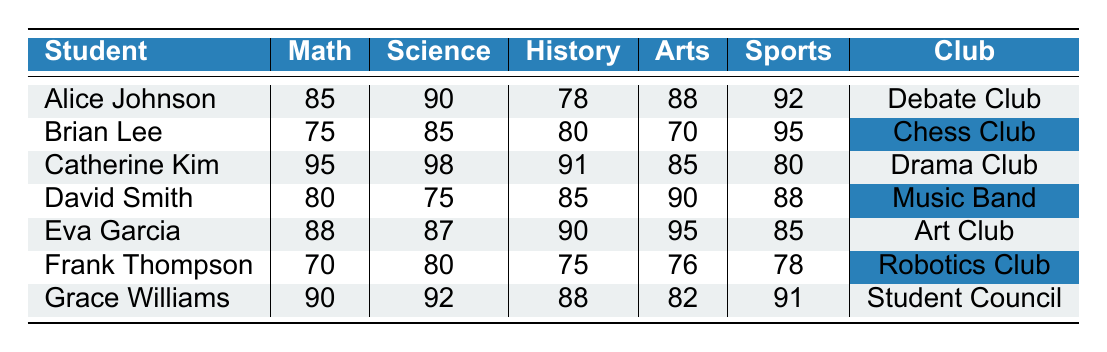What is the highest score in math? The "math" column lists all the students' scores in math. The highest score is 95, achieved by Catherine Kim.
Answer: 95 Which extracurricular club does David Smith participate in? David Smith's entry in the table shows his club participation as "Music Band."
Answer: Music Band What is the average score in sports for students in the Debate Club and Drama Club? Looking at the "sports" scores, Alice Johnson (Debate Club) has a score of 92 and Catherine Kim (Drama Club) has a score of 80. The average is calculated as (92 + 80) / 2 = 86.
Answer: 86 Is Catherine Kim's score in science higher than Eva Garcia's score in arts? Catherine Kim's score in science is 98, while Eva Garcia's score in arts is 95. Since 98 is greater than 95, the statement is true.
Answer: Yes Who has the lowest score in history among all the students? The "history" scores are compared, with the lowest score being 75, which Frank Thompson obtained.
Answer: Frank Thompson What is the total score in arts for students in the Chess Club and Robotics Club? Brian Lee (Chess Club) scored 70 in arts and Frank Thompson (Robotics Club) scored 76 in arts. Adding these gives 70 + 76 = 146.
Answer: 146 What are the scores in history and science for the student with the highest score in sports? Grace Williams has the highest score in sports at 91. Her scores are 88 in history and 92 in science.
Answer: 88 (history), 92 (science) Which student has the most balanced scores across subjects? The most balanced scores can be determined by looking at the variance in scores for each student. Grace Williams has scores ranging from 90 to 82, suggesting the least disparity among scores compared to other students.
Answer: Grace Williams 